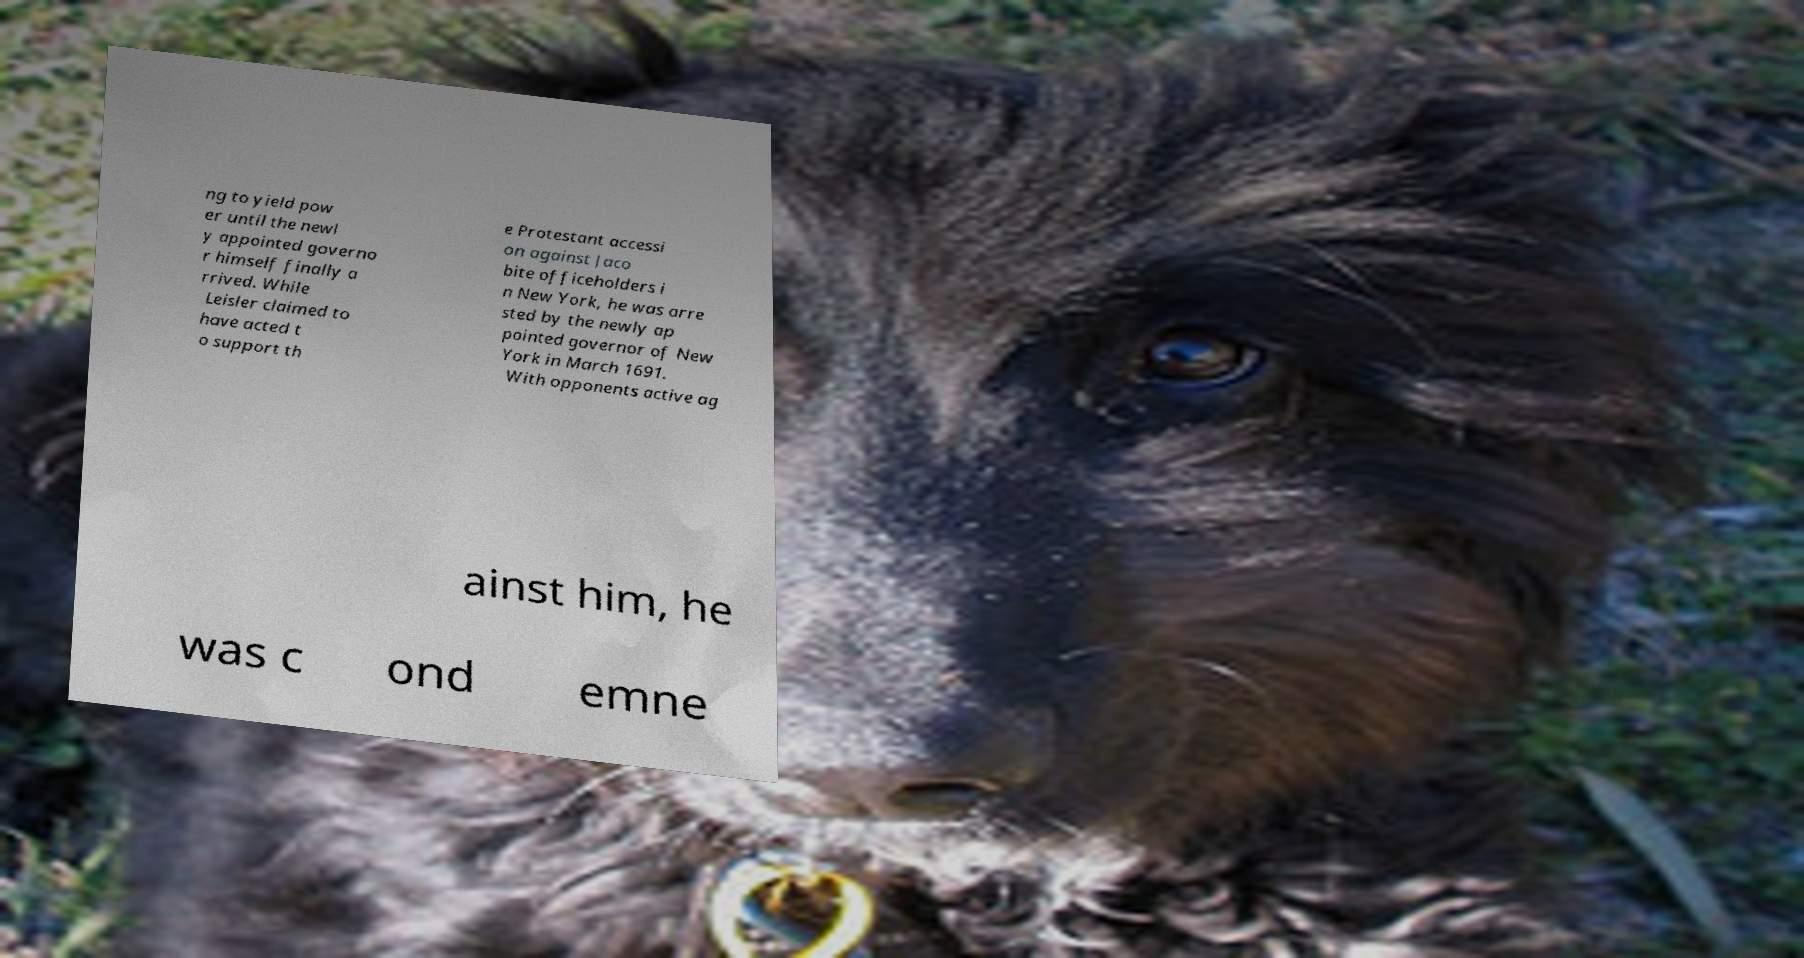Could you assist in decoding the text presented in this image and type it out clearly? ng to yield pow er until the newl y appointed governo r himself finally a rrived. While Leisler claimed to have acted t o support th e Protestant accessi on against Jaco bite officeholders i n New York, he was arre sted by the newly ap pointed governor of New York in March 1691. With opponents active ag ainst him, he was c ond emne 